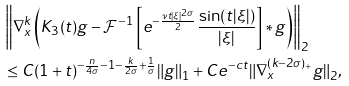Convert formula to latex. <formula><loc_0><loc_0><loc_500><loc_500>& \left \| \nabla ^ { k } _ { x } \left ( K _ { 3 } ( t ) g - \mathcal { F } ^ { - 1 } \left [ e ^ { - \frac { \nu t | \xi | ^ { 2 \sigma } } { 2 } } \frac { \sin ( t | \xi | ) } { | \xi | } \right ] \ast g \right ) \right \| _ { 2 } \\ & \leq C ( 1 + t ) ^ { - \frac { n } { 4 \sigma } - 1 - \frac { k } { 2 \sigma } + \frac { 1 } { \sigma } } \| g \| _ { 1 } + C e ^ { - c t } \| \nabla ^ { ( k - 2 \sigma ) _ { + } } _ { x } g \| _ { 2 } ,</formula> 